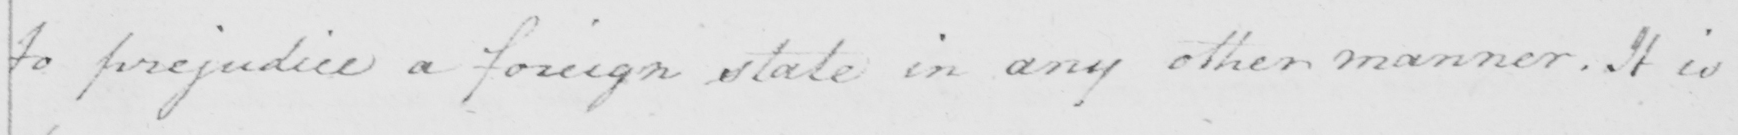Transcribe the text shown in this historical manuscript line. to prejudice a foreign state in any other manner . It is 